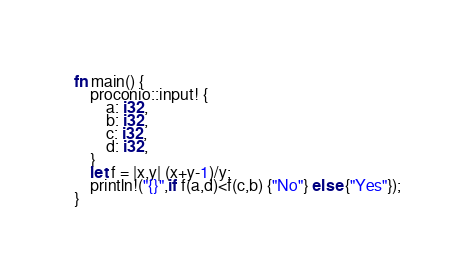Convert code to text. <code><loc_0><loc_0><loc_500><loc_500><_Rust_>fn main() {
    proconio::input! {
        a: i32,
        b: i32,
        c: i32,
        d: i32,
    }
    let f = |x,y| (x+y-1)/y;
    println!("{}",if f(a,d)<f(c,b) {"No"} else {"Yes"});
}</code> 